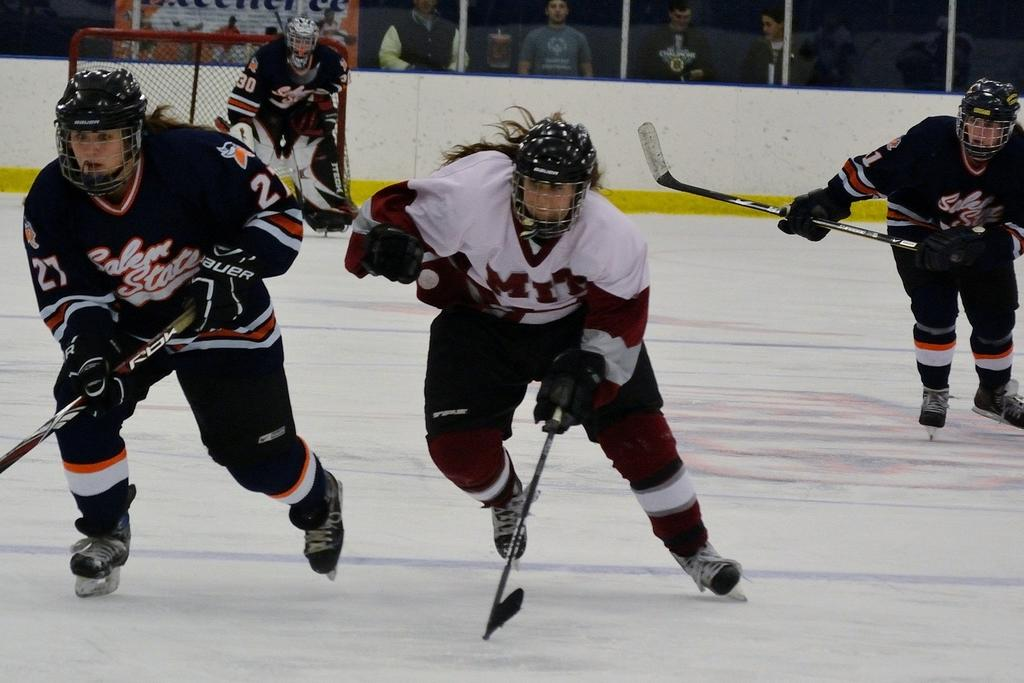What are the people in the image doing? The people in the image are playing ice hockey. What equipment are the people wearing? The people are wearing helmets. What objects are the people holding? The people are holding hockey sticks. What is the purpose of the hockey net in the background? The hockey net is used for scoring goals in ice hockey. Can you describe the other group of people in the background? There is another group of people standing in the background, but their specific actions or roles are not clear from the image. What type of calendar is hanging on the wall in the image? There is no calendar visible in the image. How often do the people wash their hockey sticks during the game? The image does not provide information about the frequency of washing hockey sticks during the game. 